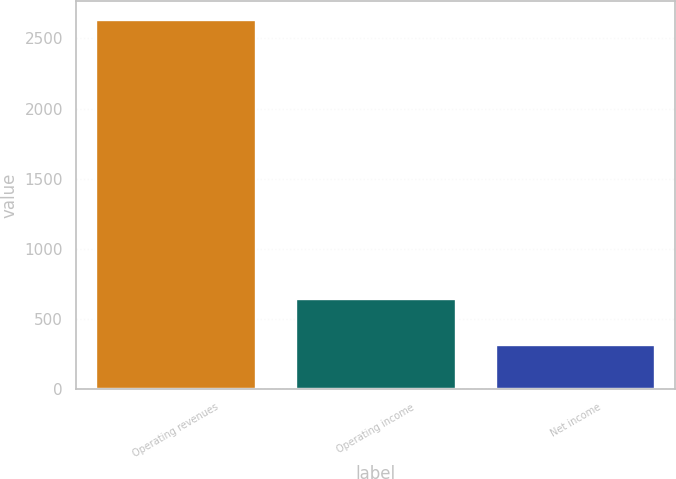<chart> <loc_0><loc_0><loc_500><loc_500><bar_chart><fcel>Operating revenues<fcel>Operating income<fcel>Net income<nl><fcel>2632<fcel>640<fcel>310<nl></chart> 